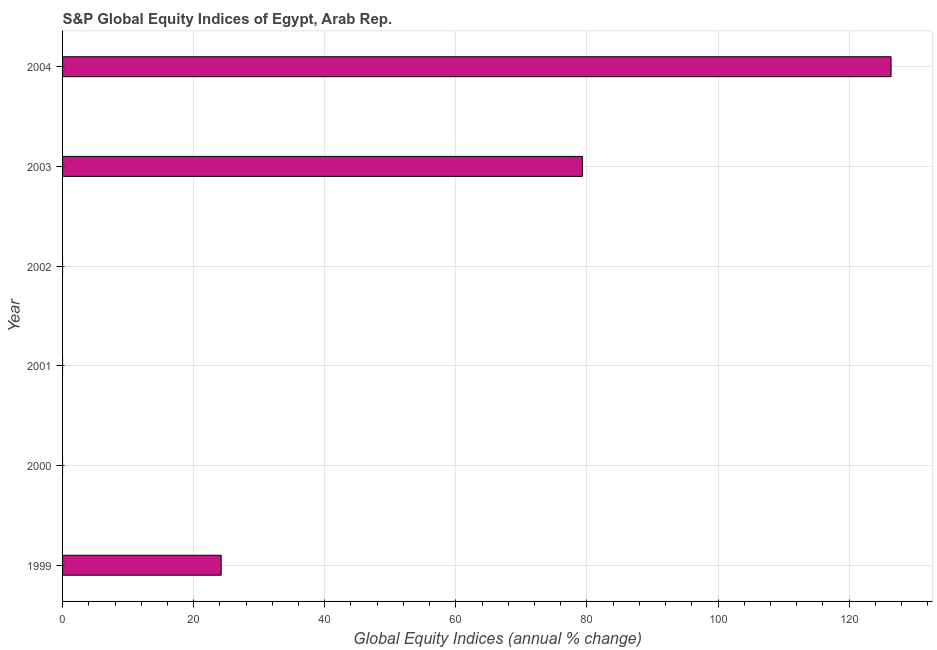Does the graph contain any zero values?
Offer a terse response. Yes. Does the graph contain grids?
Provide a succinct answer. Yes. What is the title of the graph?
Give a very brief answer. S&P Global Equity Indices of Egypt, Arab Rep. What is the label or title of the X-axis?
Offer a terse response. Global Equity Indices (annual % change). What is the s&p global equity indices in 2001?
Provide a short and direct response. 0. Across all years, what is the maximum s&p global equity indices?
Provide a short and direct response. 126.4. Across all years, what is the minimum s&p global equity indices?
Offer a very short reply. 0. In which year was the s&p global equity indices maximum?
Keep it short and to the point. 2004. What is the sum of the s&p global equity indices?
Offer a terse response. 229.91. What is the difference between the s&p global equity indices in 2003 and 2004?
Provide a succinct answer. -47.09. What is the average s&p global equity indices per year?
Provide a succinct answer. 38.32. What is the median s&p global equity indices?
Your answer should be very brief. 12.1. What is the difference between the highest and the second highest s&p global equity indices?
Your answer should be very brief. 47.09. What is the difference between the highest and the lowest s&p global equity indices?
Provide a short and direct response. 126.4. Are all the bars in the graph horizontal?
Provide a short and direct response. Yes. How many years are there in the graph?
Provide a succinct answer. 6. What is the difference between two consecutive major ticks on the X-axis?
Provide a succinct answer. 20. What is the Global Equity Indices (annual % change) in 1999?
Keep it short and to the point. 24.2. What is the Global Equity Indices (annual % change) in 2000?
Offer a terse response. 0. What is the Global Equity Indices (annual % change) of 2003?
Provide a short and direct response. 79.31. What is the Global Equity Indices (annual % change) of 2004?
Your answer should be very brief. 126.4. What is the difference between the Global Equity Indices (annual % change) in 1999 and 2003?
Offer a terse response. -55.11. What is the difference between the Global Equity Indices (annual % change) in 1999 and 2004?
Provide a short and direct response. -102.2. What is the difference between the Global Equity Indices (annual % change) in 2003 and 2004?
Your answer should be very brief. -47.09. What is the ratio of the Global Equity Indices (annual % change) in 1999 to that in 2003?
Ensure brevity in your answer.  0.3. What is the ratio of the Global Equity Indices (annual % change) in 1999 to that in 2004?
Provide a short and direct response. 0.19. What is the ratio of the Global Equity Indices (annual % change) in 2003 to that in 2004?
Your answer should be compact. 0.63. 